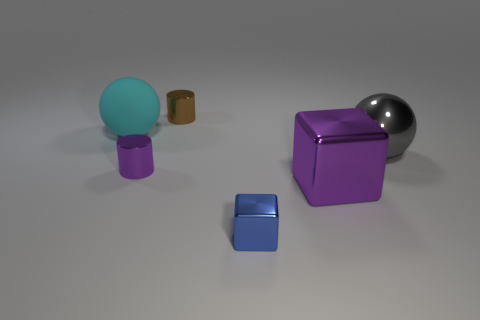Is there any other thing that is made of the same material as the cyan object?
Offer a very short reply. No. Are there any tiny blue blocks made of the same material as the tiny brown object?
Offer a terse response. Yes. The matte object is what shape?
Your answer should be compact. Sphere. Do the purple metallic cube and the cyan matte sphere have the same size?
Your answer should be very brief. Yes. How many other objects are there of the same shape as the large cyan thing?
Your answer should be compact. 1. What is the shape of the metal thing that is behind the matte sphere?
Give a very brief answer. Cylinder. Do the purple metallic thing that is to the left of the blue shiny block and the big thing to the left of the tiny metallic cube have the same shape?
Your answer should be compact. No. Are there the same number of tiny purple things in front of the rubber sphere and big cyan objects?
Your answer should be very brief. Yes. What is the material of the large purple object that is the same shape as the tiny blue shiny thing?
Your response must be concise. Metal. What shape is the big object in front of the small metal cylinder that is to the left of the brown metal cylinder?
Make the answer very short. Cube. 